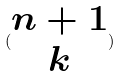Convert formula to latex. <formula><loc_0><loc_0><loc_500><loc_500>( \begin{matrix} n + 1 \\ k \end{matrix} )</formula> 